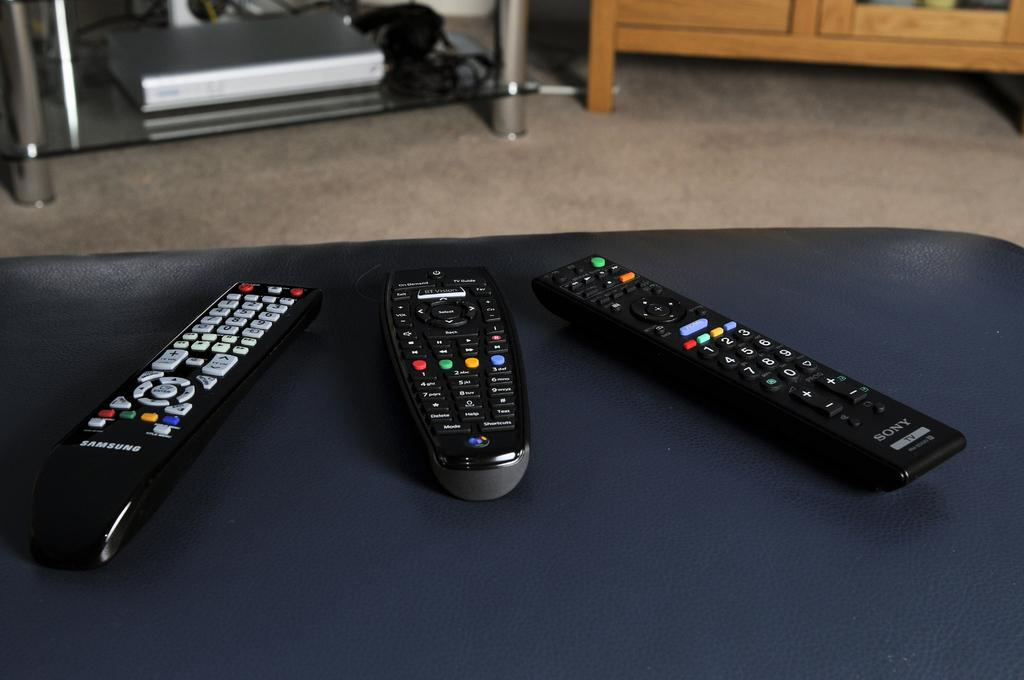Provide a one-sentence caption for the provided image. Three remote controls, one is Samsung, another is Sony. 